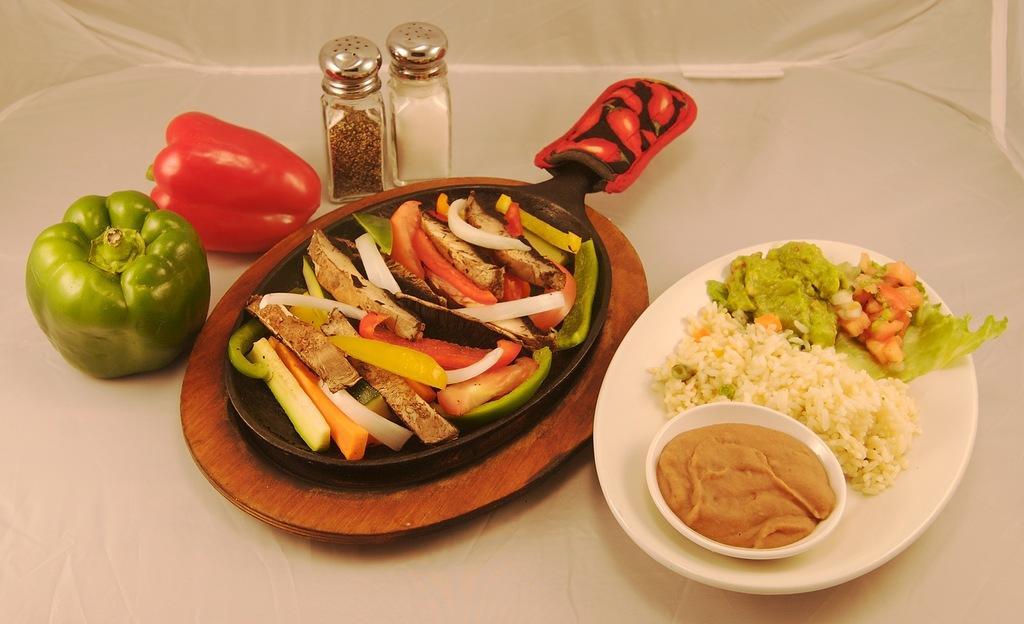Please provide a concise description of this image. On the table i can see the green capsicum, red capsicum, salt bottle, black pepper bottle, wooden pad, steel pan, plate and bowl. In the pan we can see the pieces of tomatoes, cucumber and other vegetable. In a plate i can see the rice and other food item. 